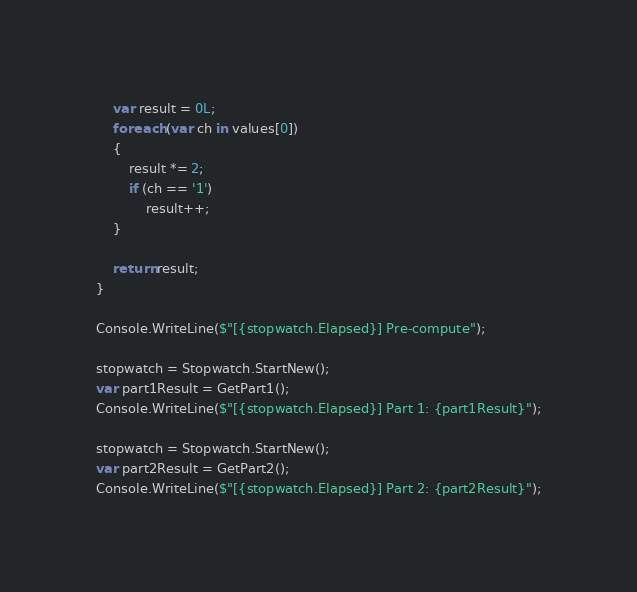<code> <loc_0><loc_0><loc_500><loc_500><_C#_>
	var result = 0L;
	foreach (var ch in values[0])
	{
		result *= 2;
		if (ch == '1')
			result++;
	}

	return result;
}

Console.WriteLine($"[{stopwatch.Elapsed}] Pre-compute");

stopwatch = Stopwatch.StartNew();
var part1Result = GetPart1();
Console.WriteLine($"[{stopwatch.Elapsed}] Part 1: {part1Result}");

stopwatch = Stopwatch.StartNew();
var part2Result = GetPart2();
Console.WriteLine($"[{stopwatch.Elapsed}] Part 2: {part2Result}");
</code> 